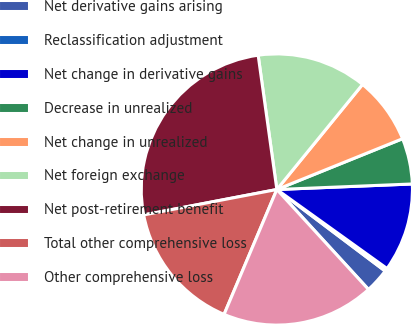Convert chart. <chart><loc_0><loc_0><loc_500><loc_500><pie_chart><fcel>Net derivative gains arising<fcel>Reclassification adjustment<fcel>Net change in derivative gains<fcel>Decrease in unrealized<fcel>Net change in unrealized<fcel>Net foreign exchange<fcel>Net post-retirement benefit<fcel>Total other comprehensive loss<fcel>Other comprehensive loss<nl><fcel>2.92%<fcel>0.37%<fcel>10.55%<fcel>5.46%<fcel>8.0%<fcel>13.09%<fcel>25.8%<fcel>15.63%<fcel>18.17%<nl></chart> 